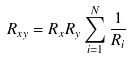Convert formula to latex. <formula><loc_0><loc_0><loc_500><loc_500>R _ { x y } = R _ { x } R _ { y } \sum _ { i = 1 } ^ { N } { \frac { 1 } { R _ { i } } }</formula> 